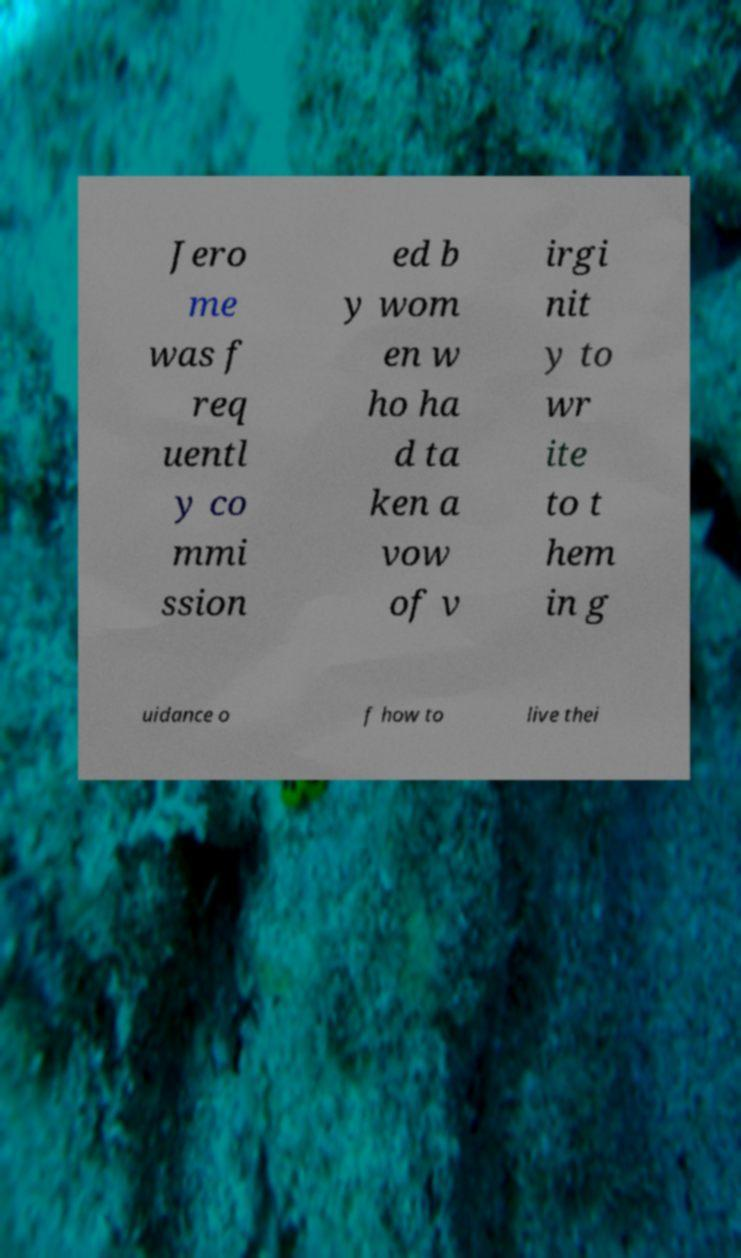There's text embedded in this image that I need extracted. Can you transcribe it verbatim? Jero me was f req uentl y co mmi ssion ed b y wom en w ho ha d ta ken a vow of v irgi nit y to wr ite to t hem in g uidance o f how to live thei 